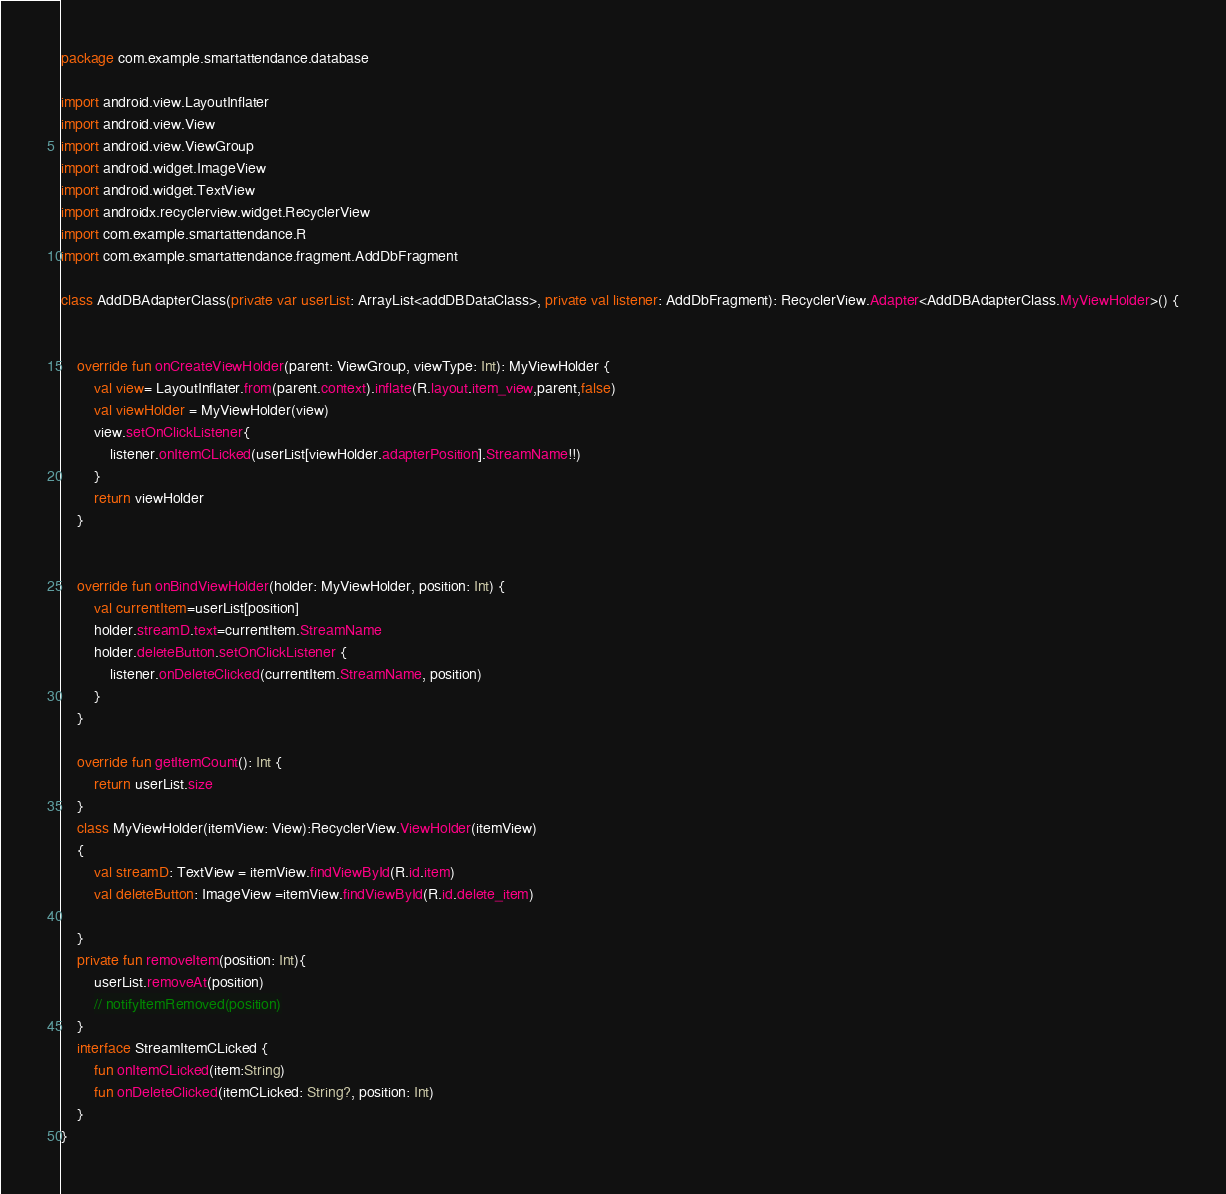Convert code to text. <code><loc_0><loc_0><loc_500><loc_500><_Kotlin_>package com.example.smartattendance.database

import android.view.LayoutInflater
import android.view.View
import android.view.ViewGroup
import android.widget.ImageView
import android.widget.TextView
import androidx.recyclerview.widget.RecyclerView
import com.example.smartattendance.R
import com.example.smartattendance.fragment.AddDbFragment

class AddDBAdapterClass(private var userList: ArrayList<addDBDataClass>, private val listener: AddDbFragment): RecyclerView.Adapter<AddDBAdapterClass.MyViewHolder>() {


    override fun onCreateViewHolder(parent: ViewGroup, viewType: Int): MyViewHolder {
        val view= LayoutInflater.from(parent.context).inflate(R.layout.item_view,parent,false)
        val viewHolder = MyViewHolder(view)
        view.setOnClickListener{
            listener.onItemCLicked(userList[viewHolder.adapterPosition].StreamName!!)
        }
        return viewHolder
    }


    override fun onBindViewHolder(holder: MyViewHolder, position: Int) {
        val currentItem=userList[position]
        holder.streamD.text=currentItem.StreamName
        holder.deleteButton.setOnClickListener {
            listener.onDeleteClicked(currentItem.StreamName, position)
        }
    }

    override fun getItemCount(): Int {
        return userList.size
    }
    class MyViewHolder(itemView: View):RecyclerView.ViewHolder(itemView)
    {
        val streamD: TextView = itemView.findViewById(R.id.item)
        val deleteButton: ImageView =itemView.findViewById(R.id.delete_item)

    }
    private fun removeItem(position: Int){
        userList.removeAt(position)
        // notifyItemRemoved(position)
    }
    interface StreamItemCLicked {
        fun onItemCLicked(item:String)
        fun onDeleteClicked(itemCLicked: String?, position: Int)
    }
}</code> 